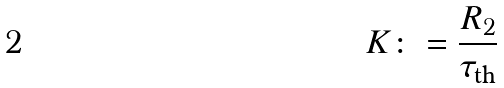Convert formula to latex. <formula><loc_0><loc_0><loc_500><loc_500>K \colon = \frac { R _ { 2 } } { \tau _ { \text {th} } }</formula> 